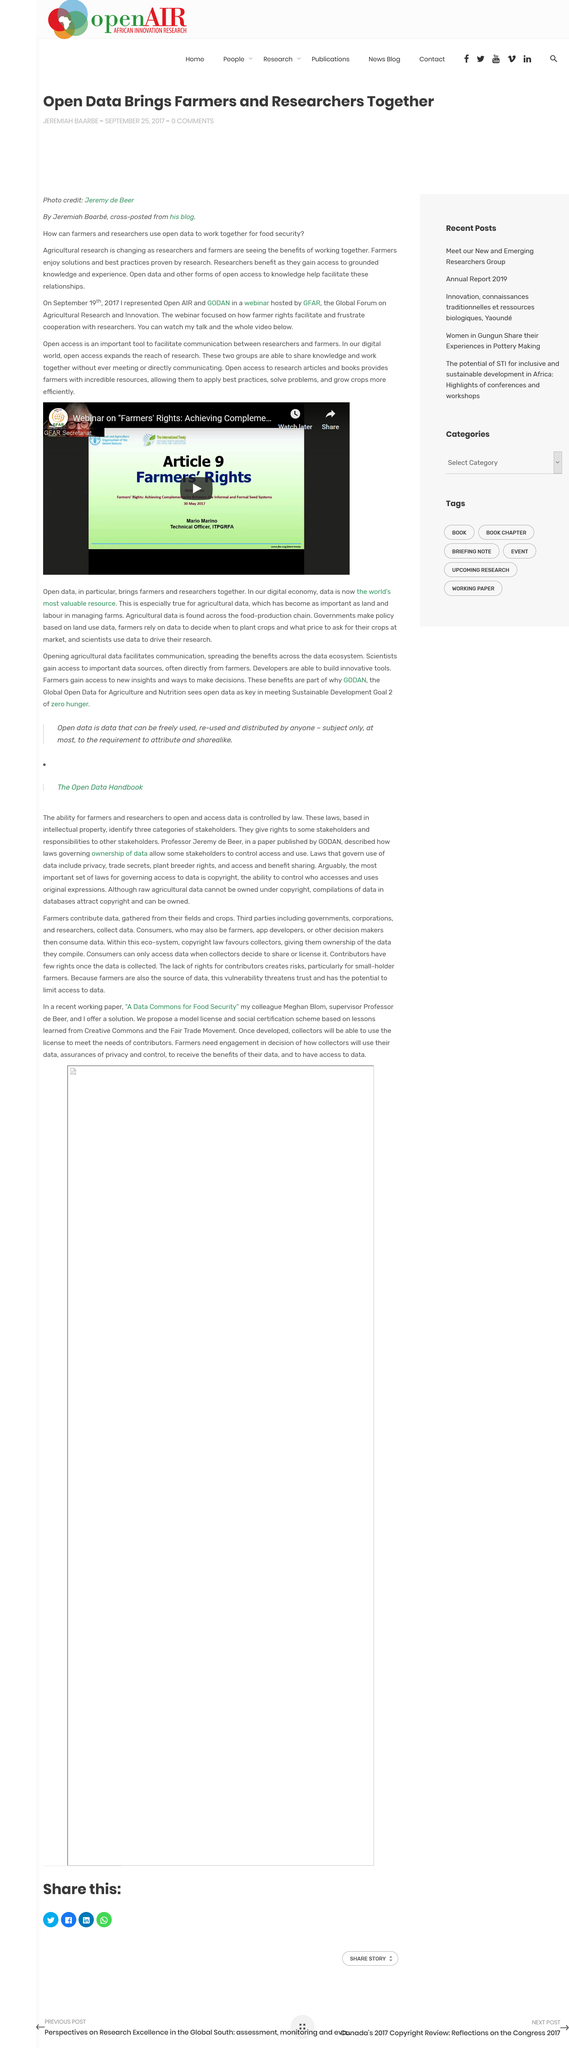Point out several critical features in this image. Laws based on intellectual property control the ability of farmers and researchers to access data. The laws that govern the use of data also cover trade secrets, privacy, plant breeder rights, and access and benefit sharing. The Open Data Handbook contains information about laws governing ownership of data. 